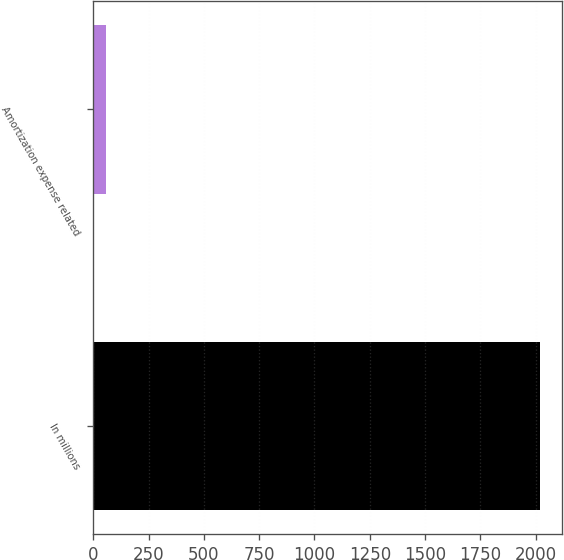Convert chart to OTSL. <chart><loc_0><loc_0><loc_500><loc_500><bar_chart><fcel>In millions<fcel>Amortization expense related<nl><fcel>2018<fcel>59<nl></chart> 